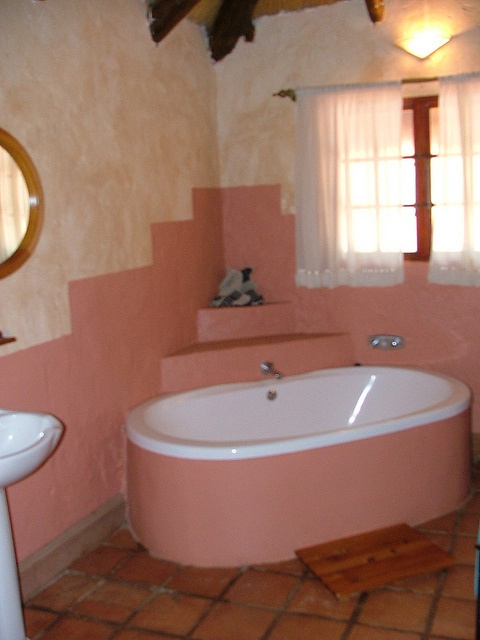Describe the objects in this image and their specific colors. I can see a sink in gray, lightgray, and darkgray tones in this image. 